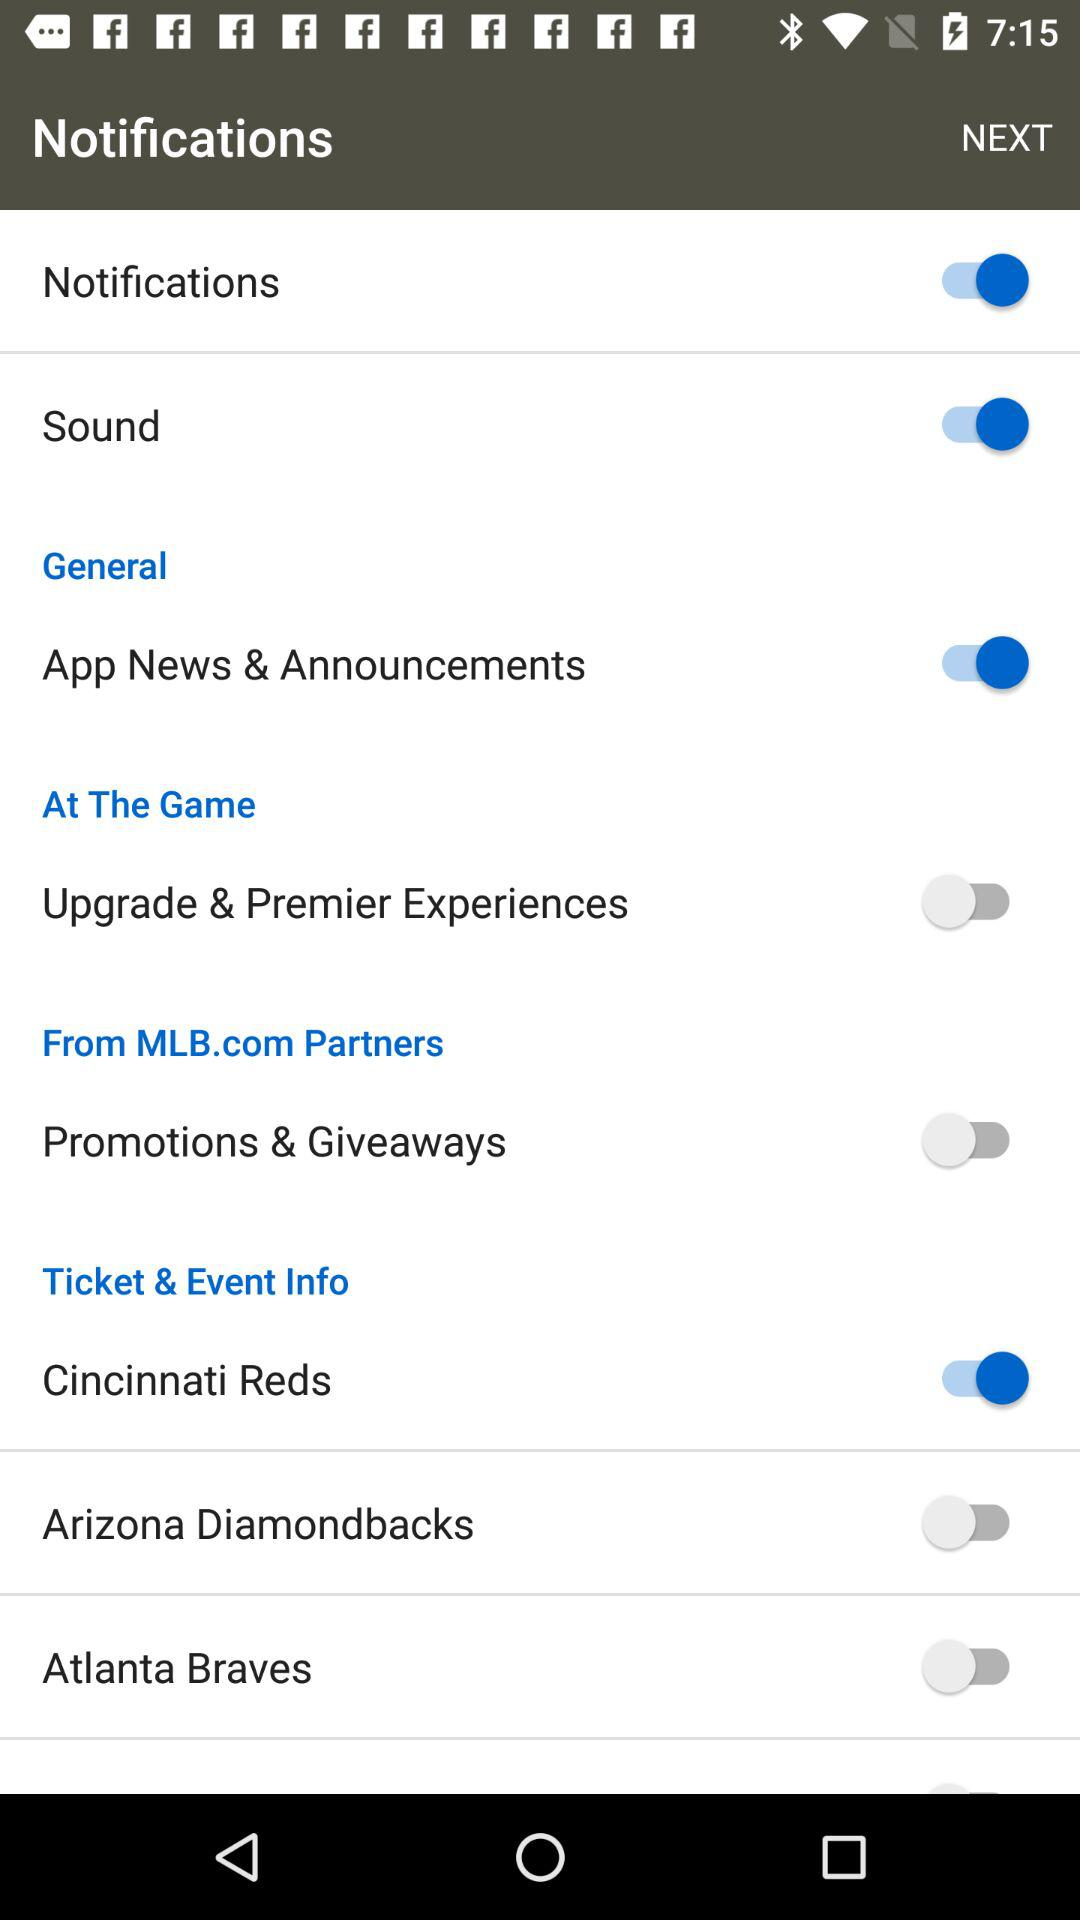What is the status of "Sound"? The status is "on". 